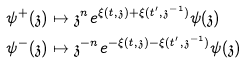<formula> <loc_0><loc_0><loc_500><loc_500>\psi ^ { + } ( \mathfrak { z } ) & \mapsto \mathfrak { z } ^ { n } e ^ { \xi ( t , \mathfrak { z } ) + \xi ( t ^ { \prime } , \mathfrak { z } ^ { - 1 } ) } \psi ( \mathfrak { z } ) \\ \psi ^ { - } ( \mathfrak { z } ) & \mapsto \mathfrak { z } ^ { - n } e ^ { - \xi ( t , \mathfrak { z } ) - \xi ( t ^ { \prime } , \mathfrak { z } ^ { - 1 } ) } \psi ( \mathfrak { z } )</formula> 